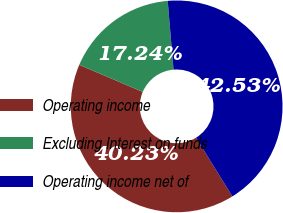Convert chart. <chart><loc_0><loc_0><loc_500><loc_500><pie_chart><fcel>Operating income<fcel>Excluding Interest on funds<fcel>Operating income net of<nl><fcel>40.23%<fcel>17.24%<fcel>42.53%<nl></chart> 